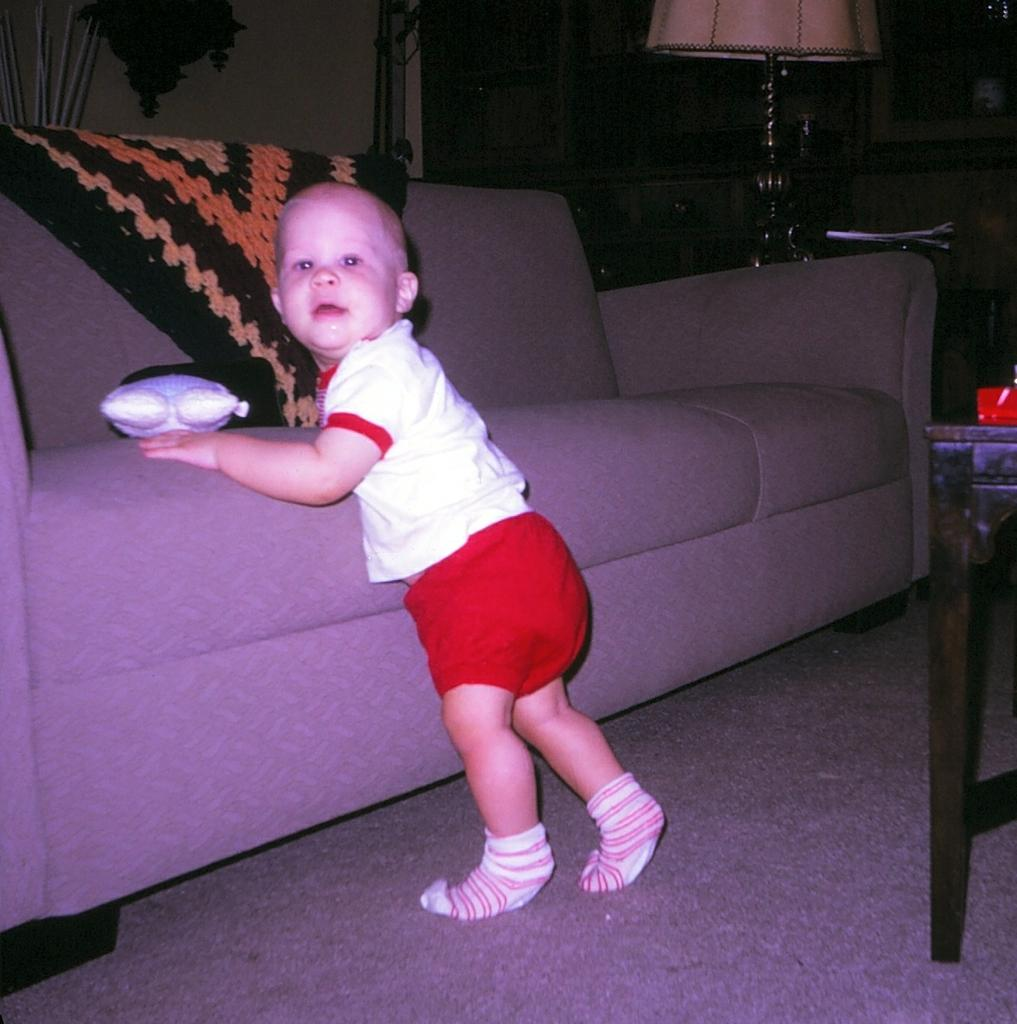What is the boy doing in the image? The boy is standing near the couch in the image. What is the boy standing on? The boy is standing on a carpet. What is covering the couch? There is a cloth on the couch. What object is on the couch? There is a toy on the couch. Can you describe any light source in the image? There is a lamp in the image. What type of background can be seen in the image? There is a wall in the image. Are there any storage units visible? Yes, there are cupboards in the image. What piece of furniture is present in the image besides the couch? There is a table in the image. What type of paper items are present in the image? There are papers in the image. How does the boy cast a spell on the toy in the image? There is no indication in the image that the boy is casting a spell or interacting with the toy in any magical way. 